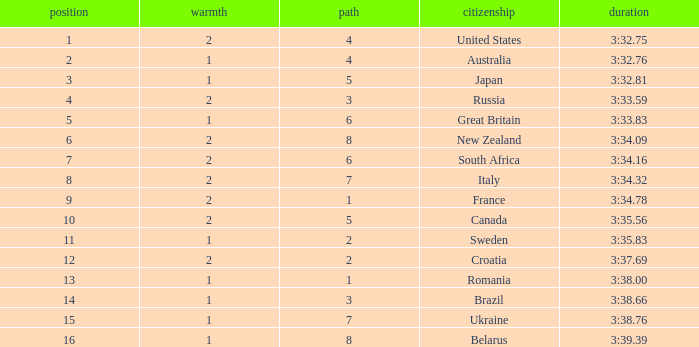Can you tell me the Time that has the Heat of 1, and the Lane of 2? 3:35.83. 